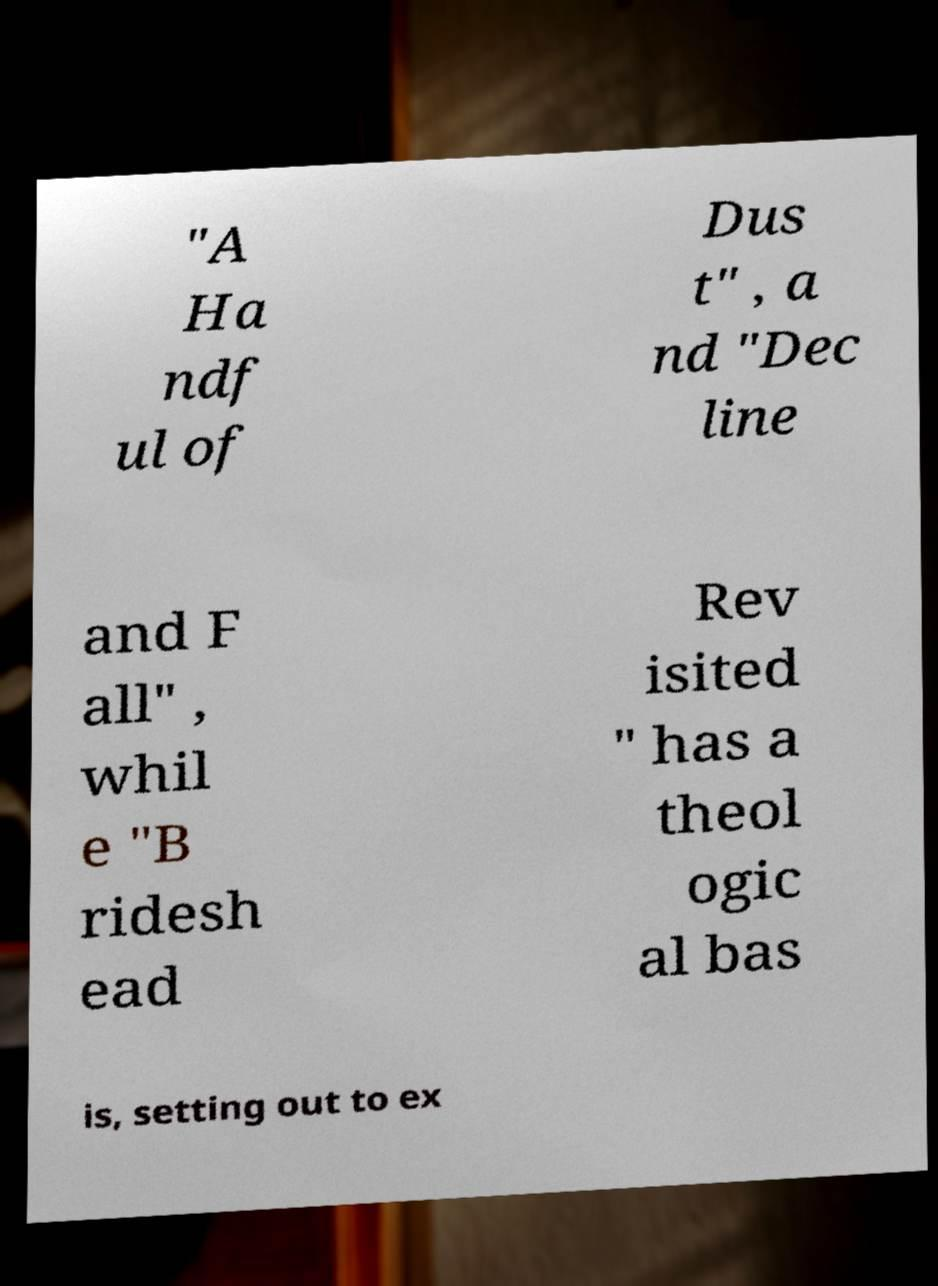What messages or text are displayed in this image? I need them in a readable, typed format. "A Ha ndf ul of Dus t" , a nd "Dec line and F all" , whil e "B ridesh ead Rev isited " has a theol ogic al bas is, setting out to ex 